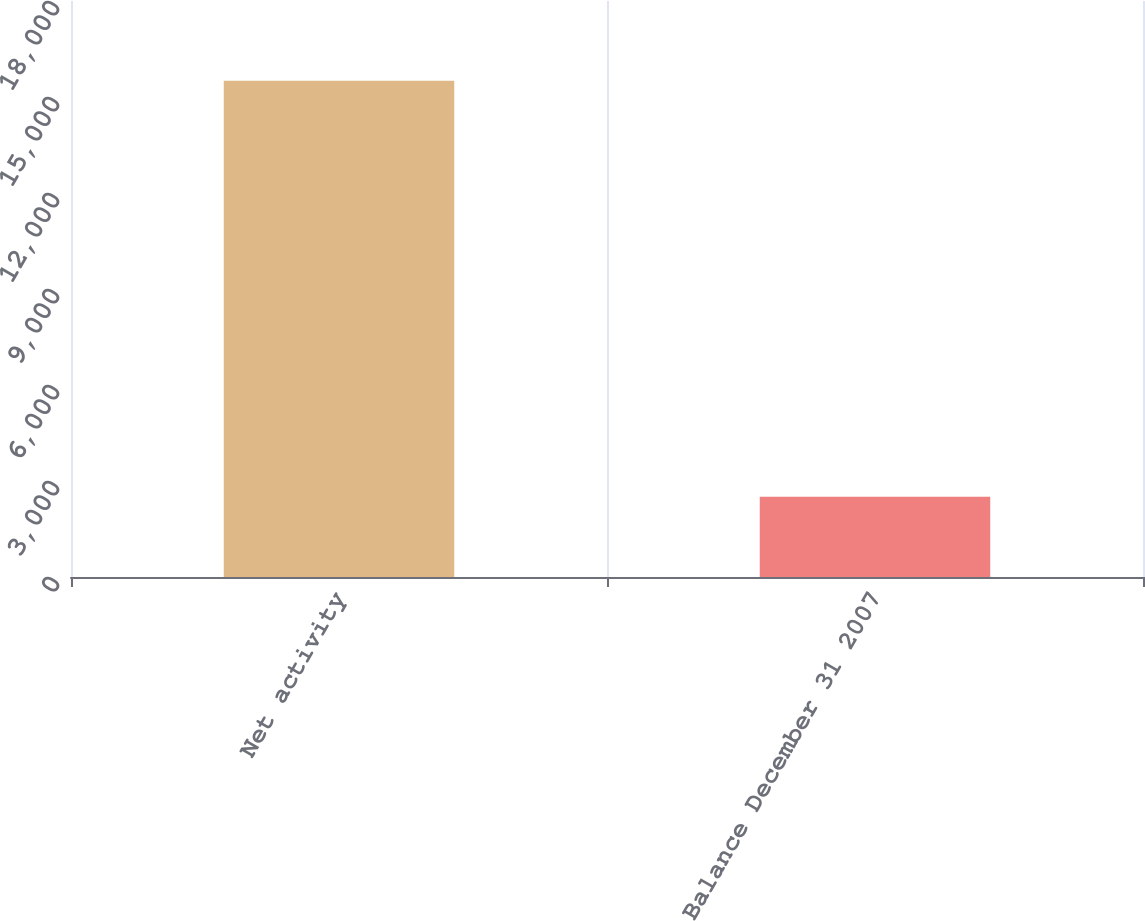Convert chart. <chart><loc_0><loc_0><loc_500><loc_500><bar_chart><fcel>Net activity<fcel>Balance December 31 2007<nl><fcel>15508<fcel>2511<nl></chart> 